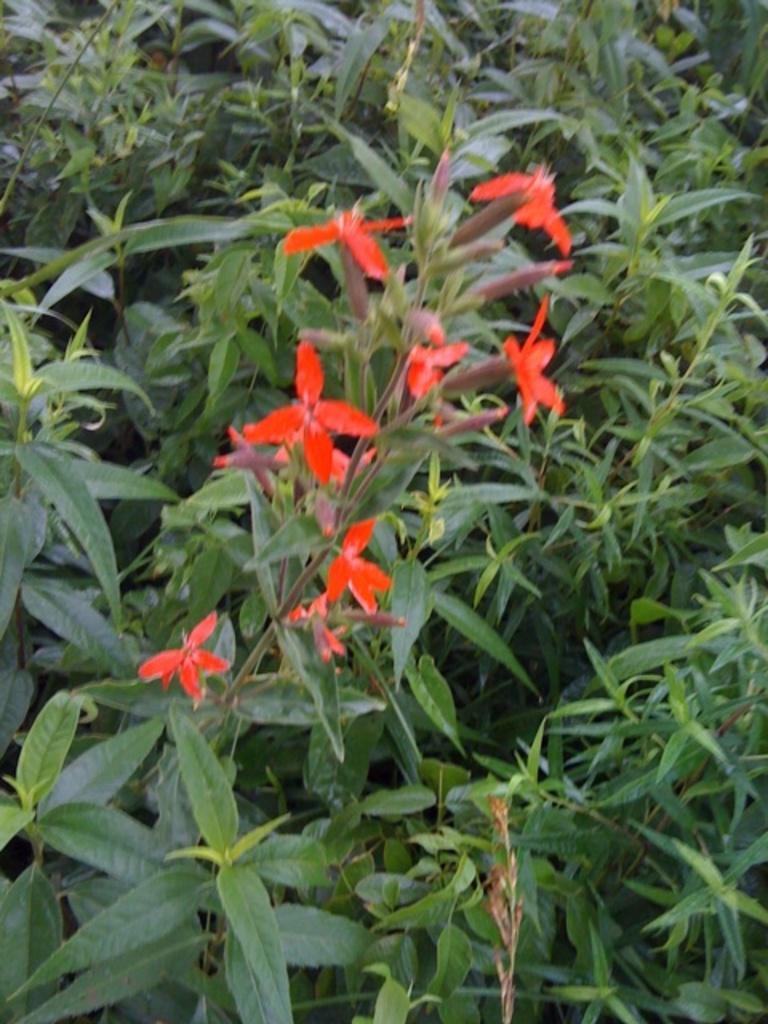Please provide a concise description of this image. In this image there are some red flowers on the stem of plant which is in between other plants. 